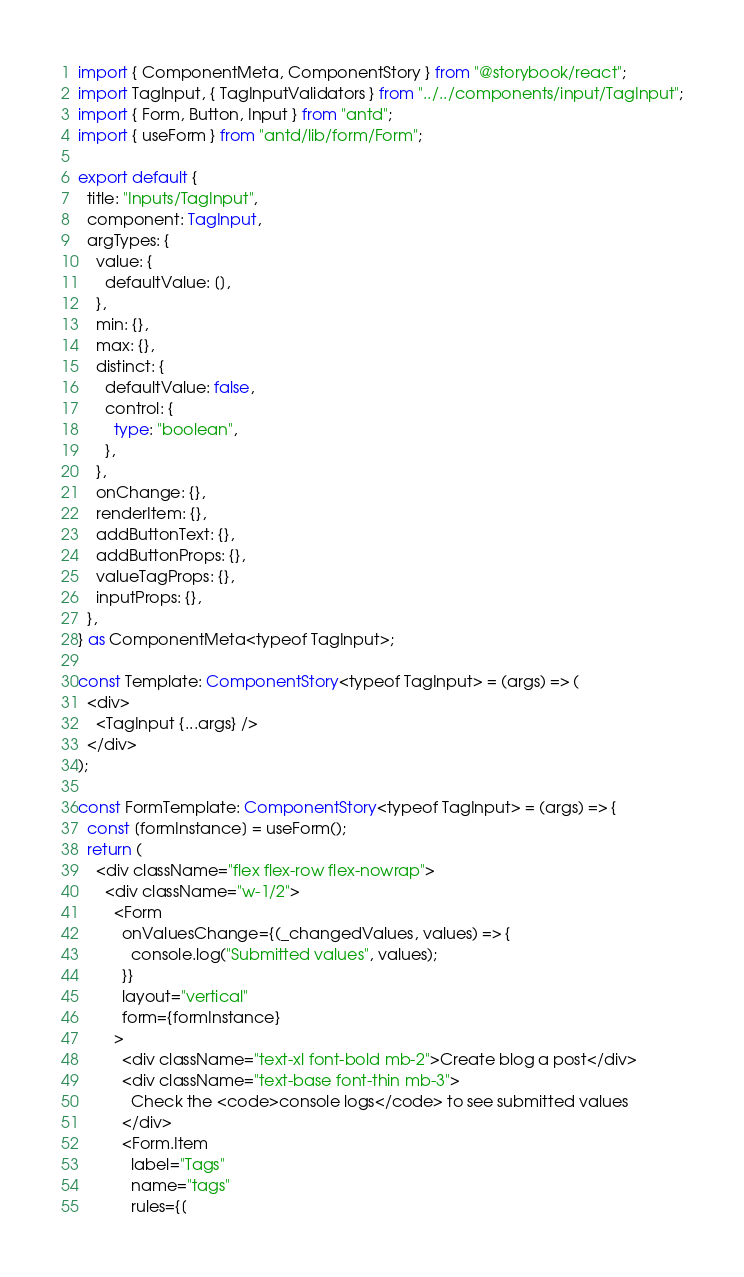<code> <loc_0><loc_0><loc_500><loc_500><_TypeScript_>import { ComponentMeta, ComponentStory } from "@storybook/react";
import TagInput, { TagInputValidators } from "../../components/input/TagInput";
import { Form, Button, Input } from "antd";
import { useForm } from "antd/lib/form/Form";

export default {
  title: "Inputs/TagInput",
  component: TagInput,
  argTypes: {
    value: {
      defaultValue: [],
    },
    min: {},
    max: {},
    distinct: {
      defaultValue: false,
      control: {
        type: "boolean",
      },
    },
    onChange: {},
    renderItem: {},
    addButtonText: {},
    addButtonProps: {},
    valueTagProps: {},
    inputProps: {},
  },
} as ComponentMeta<typeof TagInput>;

const Template: ComponentStory<typeof TagInput> = (args) => (
  <div>
    <TagInput {...args} />
  </div>
);

const FormTemplate: ComponentStory<typeof TagInput> = (args) => {
  const [formInstance] = useForm();
  return (
    <div className="flex flex-row flex-nowrap">
      <div className="w-1/2">
        <Form
          onValuesChange={(_changedValues, values) => {
            console.log("Submitted values", values);
          }}
          layout="vertical"
          form={formInstance}
        >
          <div className="text-xl font-bold mb-2">Create blog a post</div>
          <div className="text-base font-thin mb-3">
            Check the <code>console logs</code> to see submitted values
          </div>
          <Form.Item
            label="Tags"
            name="tags"
            rules={[</code> 